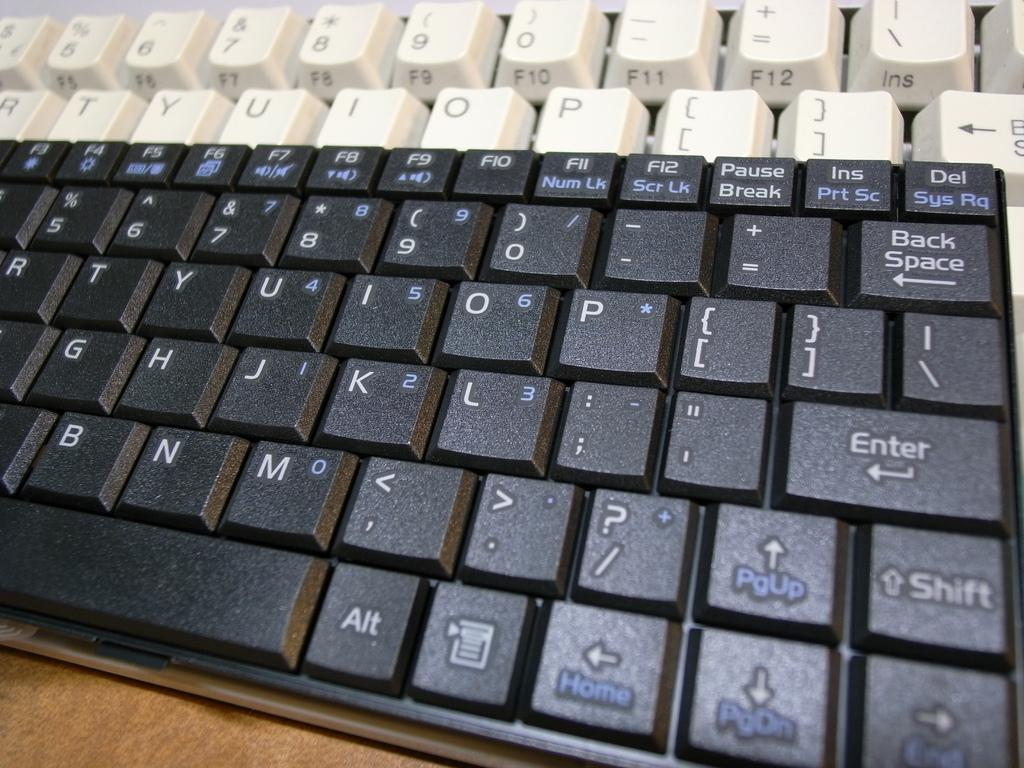<image>
Relay a brief, clear account of the picture shown. Two keyboards, one black and one white are on a desk both of which having the letter p on them. 